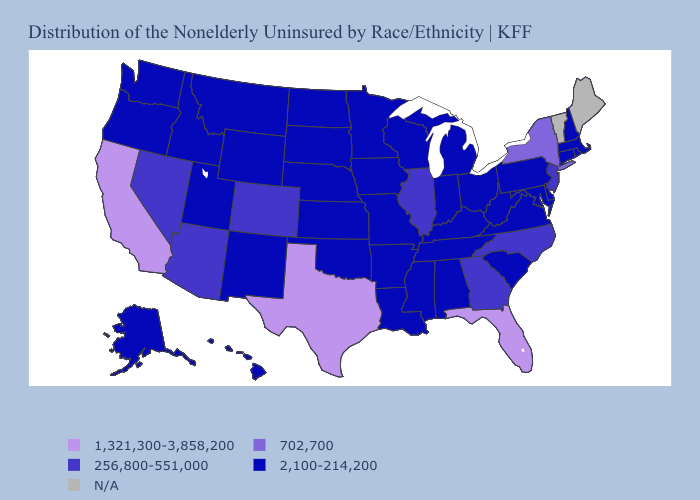Name the states that have a value in the range 702,700?
Be succinct. New York. Does Pennsylvania have the lowest value in the Northeast?
Answer briefly. Yes. Name the states that have a value in the range 2,100-214,200?
Be succinct. Alabama, Alaska, Arkansas, Connecticut, Delaware, Hawaii, Idaho, Indiana, Iowa, Kansas, Kentucky, Louisiana, Maryland, Massachusetts, Michigan, Minnesota, Mississippi, Missouri, Montana, Nebraska, New Hampshire, New Mexico, North Dakota, Ohio, Oklahoma, Oregon, Pennsylvania, Rhode Island, South Carolina, South Dakota, Tennessee, Utah, Virginia, Washington, West Virginia, Wisconsin, Wyoming. Name the states that have a value in the range 256,800-551,000?
Concise answer only. Arizona, Colorado, Georgia, Illinois, Nevada, New Jersey, North Carolina. What is the value of New Jersey?
Concise answer only. 256,800-551,000. Which states have the lowest value in the Northeast?
Quick response, please. Connecticut, Massachusetts, New Hampshire, Pennsylvania, Rhode Island. Name the states that have a value in the range 256,800-551,000?
Be succinct. Arizona, Colorado, Georgia, Illinois, Nevada, New Jersey, North Carolina. Which states have the highest value in the USA?
Concise answer only. California, Florida, Texas. Name the states that have a value in the range 1,321,300-3,858,200?
Short answer required. California, Florida, Texas. What is the value of New York?
Answer briefly. 702,700. Does New York have the highest value in the Northeast?
Quick response, please. Yes. Which states hav the highest value in the South?
Quick response, please. Florida, Texas. Does the map have missing data?
Be succinct. Yes. Which states have the highest value in the USA?
Write a very short answer. California, Florida, Texas. Is the legend a continuous bar?
Short answer required. No. 